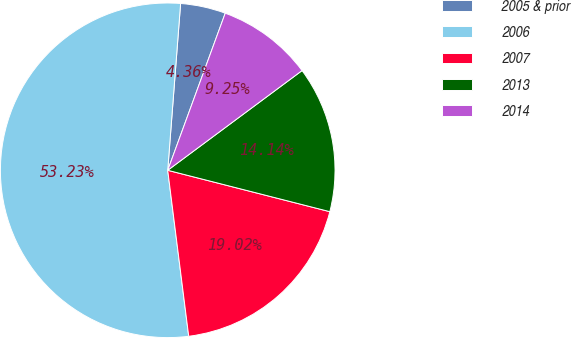Convert chart. <chart><loc_0><loc_0><loc_500><loc_500><pie_chart><fcel>2005 & prior<fcel>2006<fcel>2007<fcel>2013<fcel>2014<nl><fcel>4.36%<fcel>53.23%<fcel>19.02%<fcel>14.14%<fcel>9.25%<nl></chart> 